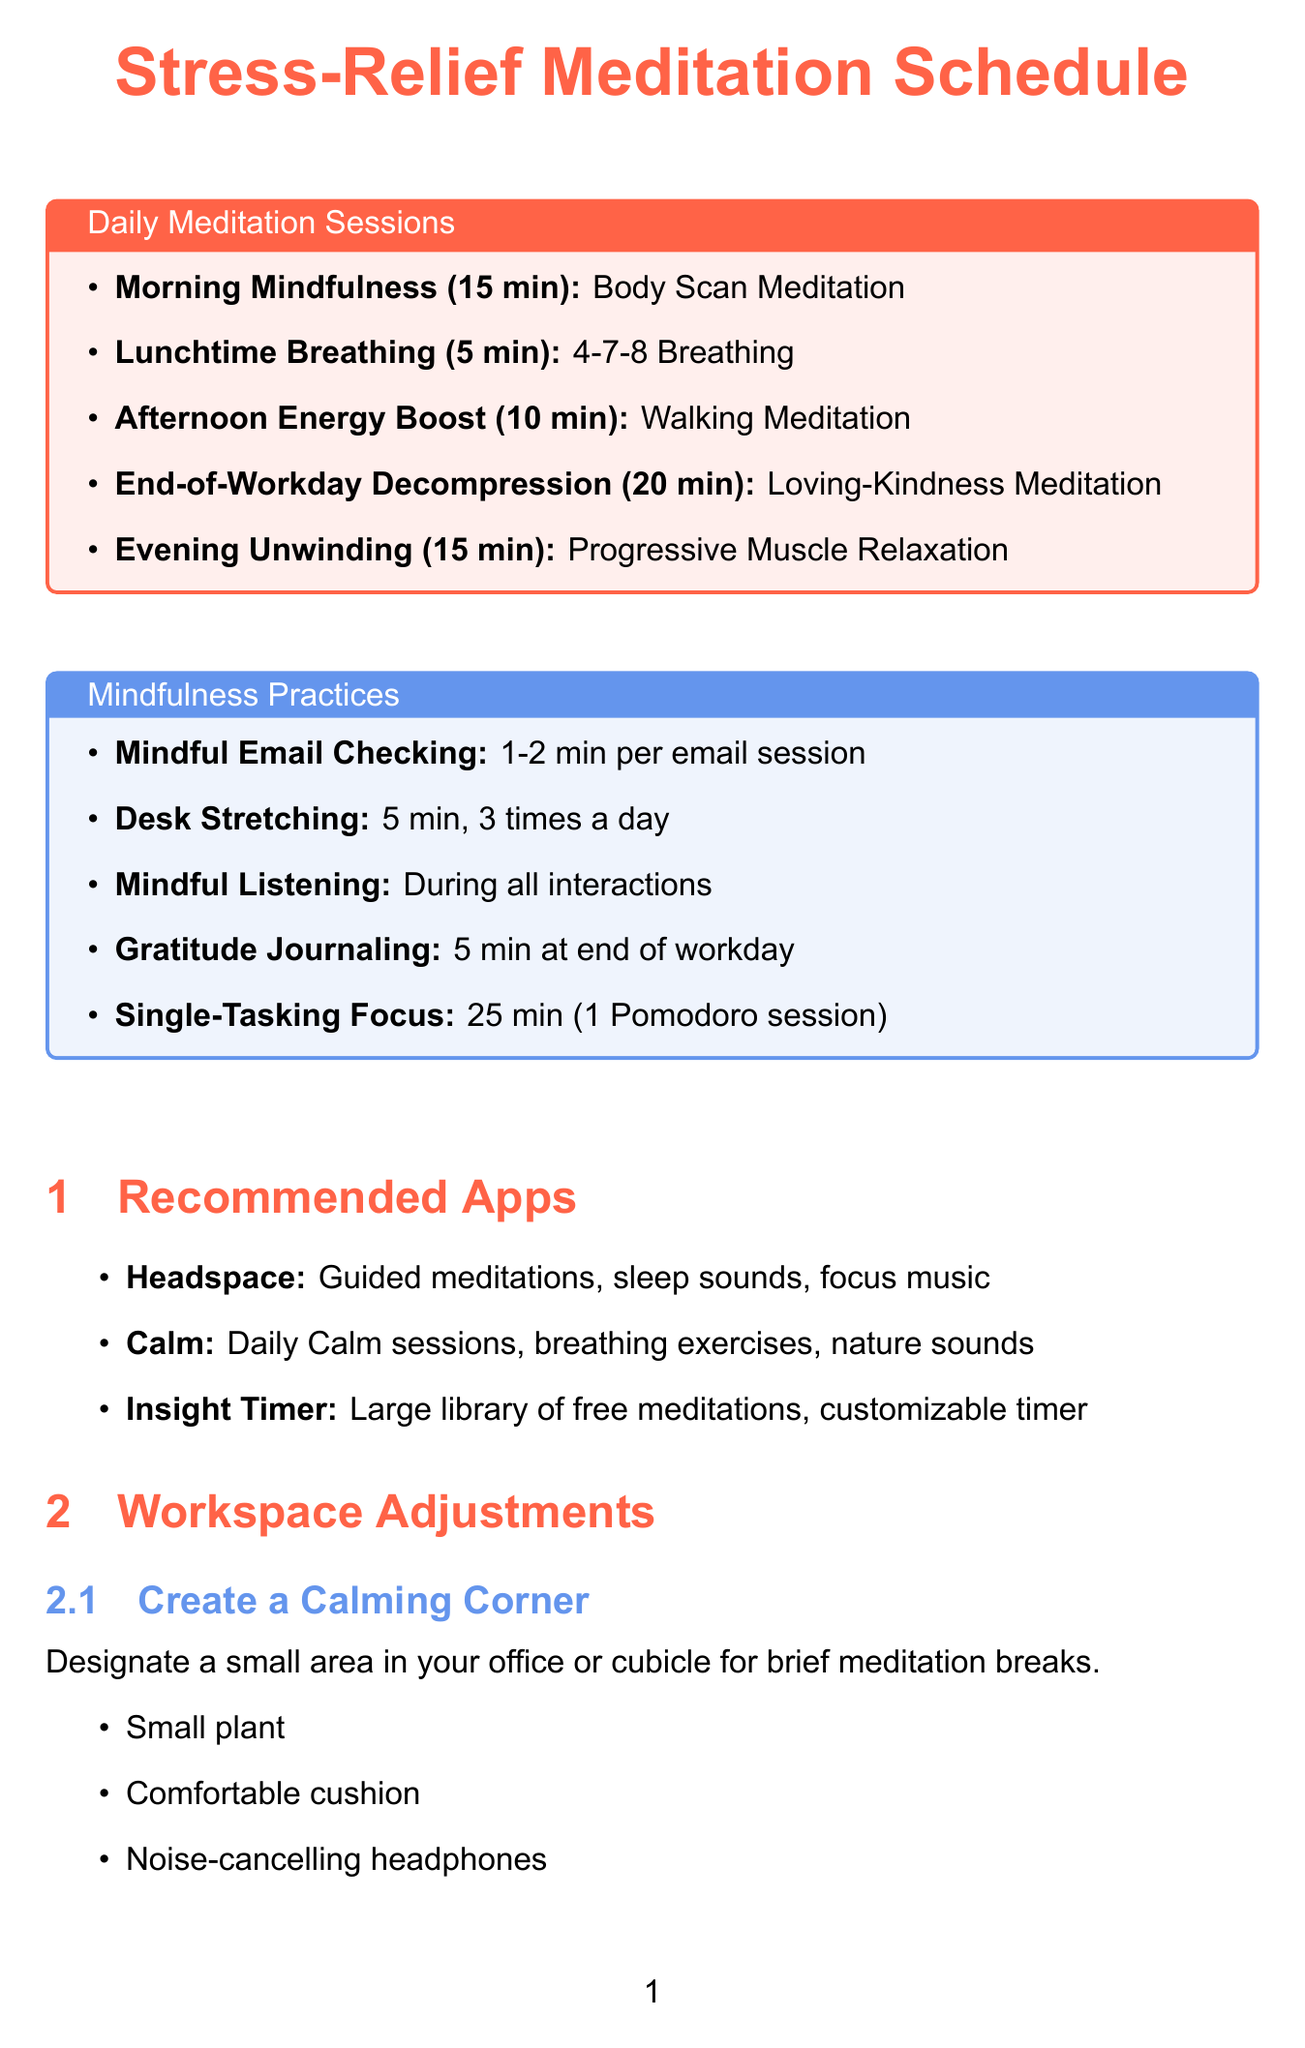What is the duration of the Morning Mindfulness session? The duration of the Morning Mindfulness session is explicitly stated in the document.
Answer: 15 minutes What technique is used in the End-of-Workday Decompression session? The document specifies the technique used for each meditation session, including the End-of-Workday Decompression.
Answer: Loving-Kindness Meditation How many mindfulness practices are listed? The number of mindfulness practices can be counted from the section of the document that lists them.
Answer: 5 What is the duration of the Lunchtime Breathing Exercise? The duration for the Lunchtime Breathing Exercise is provided directly in the document.
Answer: 5 minutes Which meditation technique is aimed at increasing alertness? The document mentions the benefits and focus of each meditation session, allowing identification of the one aimed at increasing alertness.
Answer: Walking Meditation What is the benefit of Gratitude Journaling? The document includes a benefit for each mindfulness practice, including Gratitude Journaling.
Answer: Increases job satisfaction and overall well-being How many times a day should Desk Stretching be performed? The frequency of Desk Stretching is noted in the document under the specific mindfulness practice.
Answer: 3 times a day Which app features guided meditations and sleep sounds? The document lists recommended apps along with their features, making it easy to identify the one that includes guided meditations and sleep sounds.
Answer: Headspace What items are suggested for creating a calming corner? The document provides specific items that can be used to create a calming corner for meditation breaks.
Answer: Small plant, Comfortable cushion, Noise-cancelling headphones 